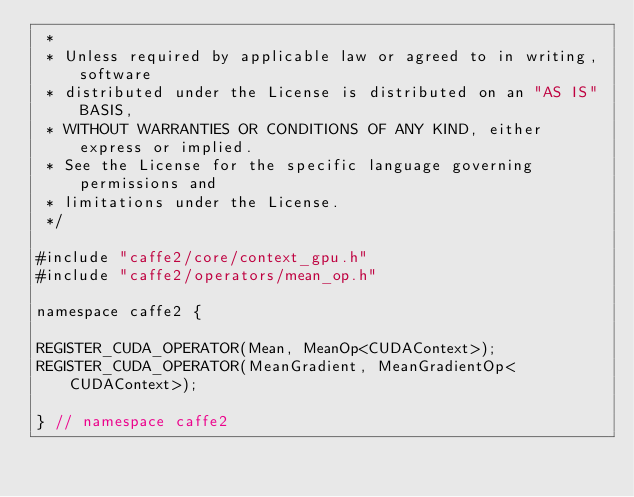Convert code to text. <code><loc_0><loc_0><loc_500><loc_500><_Cuda_> *
 * Unless required by applicable law or agreed to in writing, software
 * distributed under the License is distributed on an "AS IS" BASIS,
 * WITHOUT WARRANTIES OR CONDITIONS OF ANY KIND, either express or implied.
 * See the License for the specific language governing permissions and
 * limitations under the License.
 */

#include "caffe2/core/context_gpu.h"
#include "caffe2/operators/mean_op.h"

namespace caffe2 {

REGISTER_CUDA_OPERATOR(Mean, MeanOp<CUDAContext>);
REGISTER_CUDA_OPERATOR(MeanGradient, MeanGradientOp<CUDAContext>);

} // namespace caffe2
</code> 